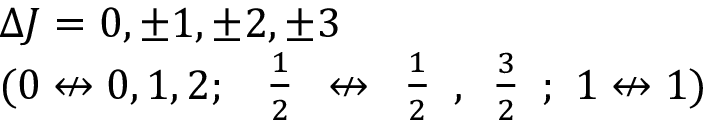Convert formula to latex. <formula><loc_0><loc_0><loc_500><loc_500>\begin{array} { l } { \Delta J = 0 , \pm 1 , \pm 2 , \pm 3 } \\ { ( 0 \not \leftrightarrow 0 , 1 , 2 ; \ { \begin{array} { l } { { \frac { 1 } { 2 } } } \end{array} } \not \leftrightarrow { \begin{array} { l } { { \frac { 1 } { 2 } } } \end{array} } , { \begin{array} { l } { { \frac { 3 } { 2 } } } \end{array} } ; \ 1 \not \leftrightarrow 1 ) } \end{array}</formula> 